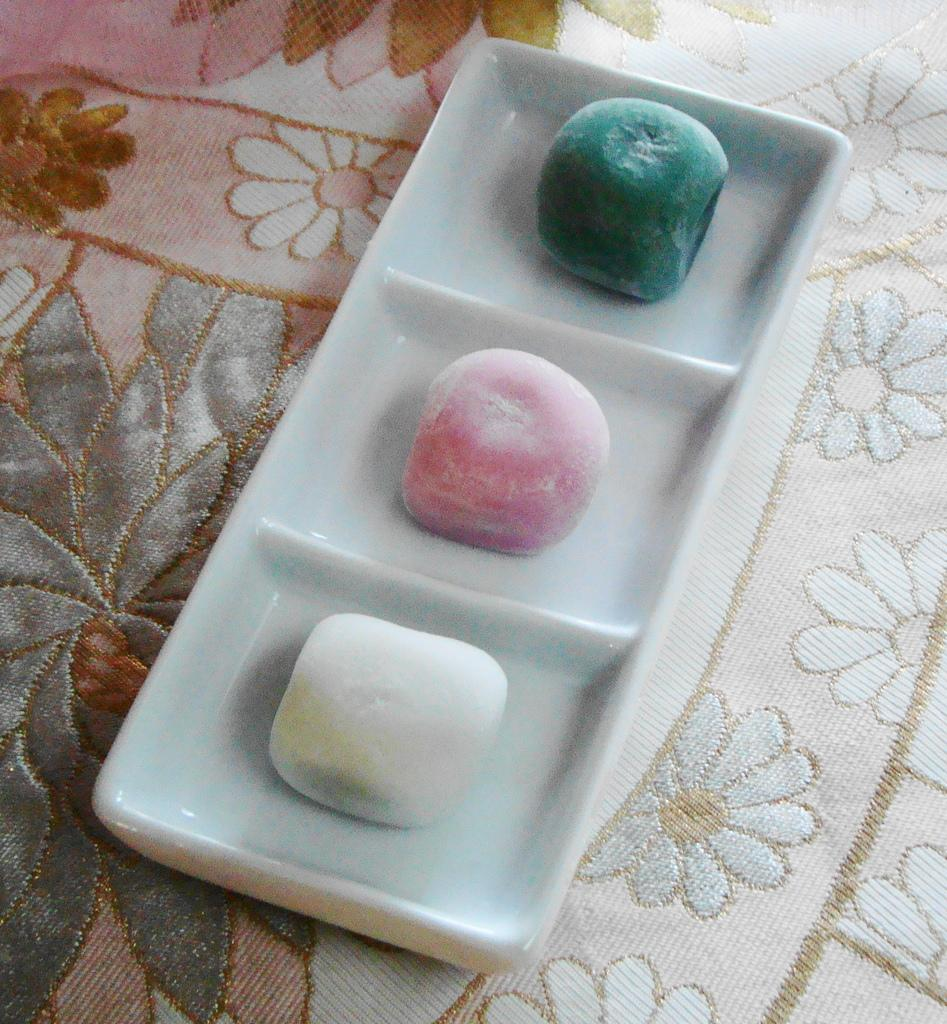What type of food items are present in the image? There are candies in the image. How are the candies arranged or organized? The candies are placed in a tray. What is the tray with candies resting on? The tray with candies is placed on a cloth. What type of tax is being discussed in the image? There is no discussion of tax in the image; it features candies placed in a tray on a cloth. 